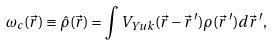<formula> <loc_0><loc_0><loc_500><loc_500>\omega _ { c } ( \vec { r } ) \equiv \hat { \rho } ( \vec { r } ) = \int V _ { Y u k } ( \vec { r } - \vec { r } \, ^ { \prime } ) \rho ( \vec { r } \, ^ { \prime } ) d \vec { r } \, ^ { \prime } ,</formula> 